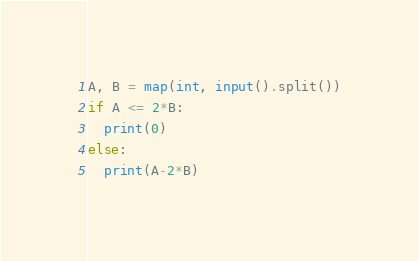<code> <loc_0><loc_0><loc_500><loc_500><_Python_>A, B = map(int, input().split())
if A <= 2*B:
  print(0)
else:
  print(A-2*B)</code> 